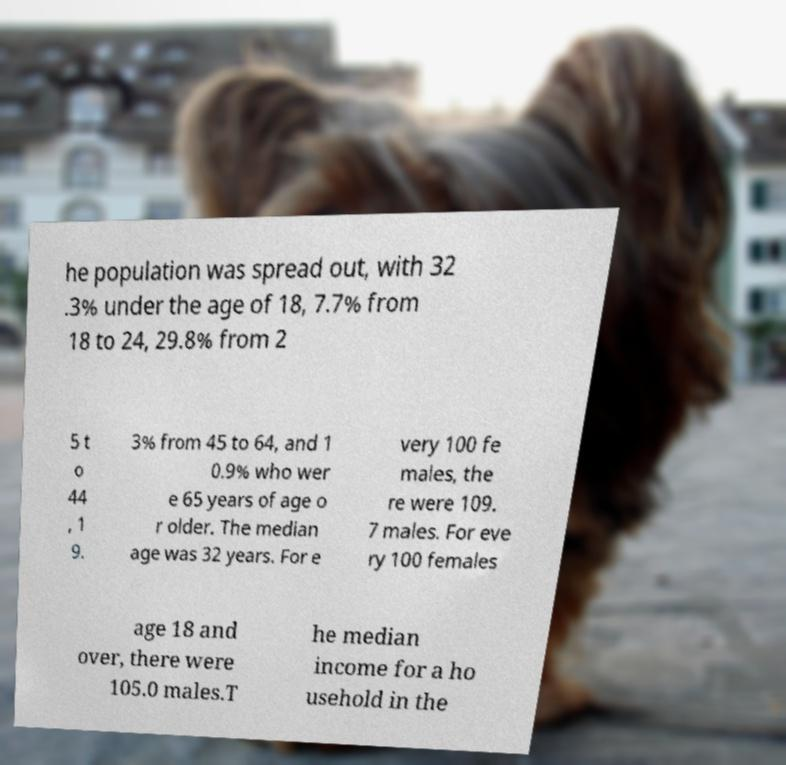Please identify and transcribe the text found in this image. he population was spread out, with 32 .3% under the age of 18, 7.7% from 18 to 24, 29.8% from 2 5 t o 44 , 1 9. 3% from 45 to 64, and 1 0.9% who wer e 65 years of age o r older. The median age was 32 years. For e very 100 fe males, the re were 109. 7 males. For eve ry 100 females age 18 and over, there were 105.0 males.T he median income for a ho usehold in the 